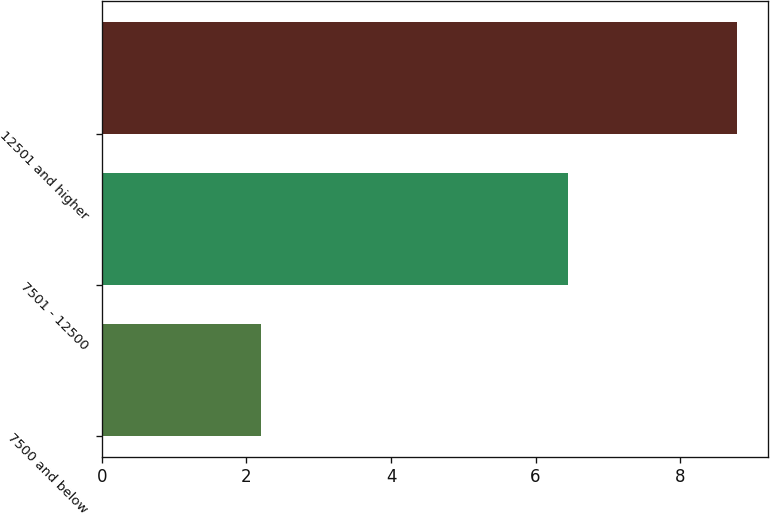Convert chart. <chart><loc_0><loc_0><loc_500><loc_500><bar_chart><fcel>7500 and below<fcel>7501 - 12500<fcel>12501 and higher<nl><fcel>2.2<fcel>6.45<fcel>8.78<nl></chart> 